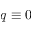Convert formula to latex. <formula><loc_0><loc_0><loc_500><loc_500>q \equiv 0</formula> 